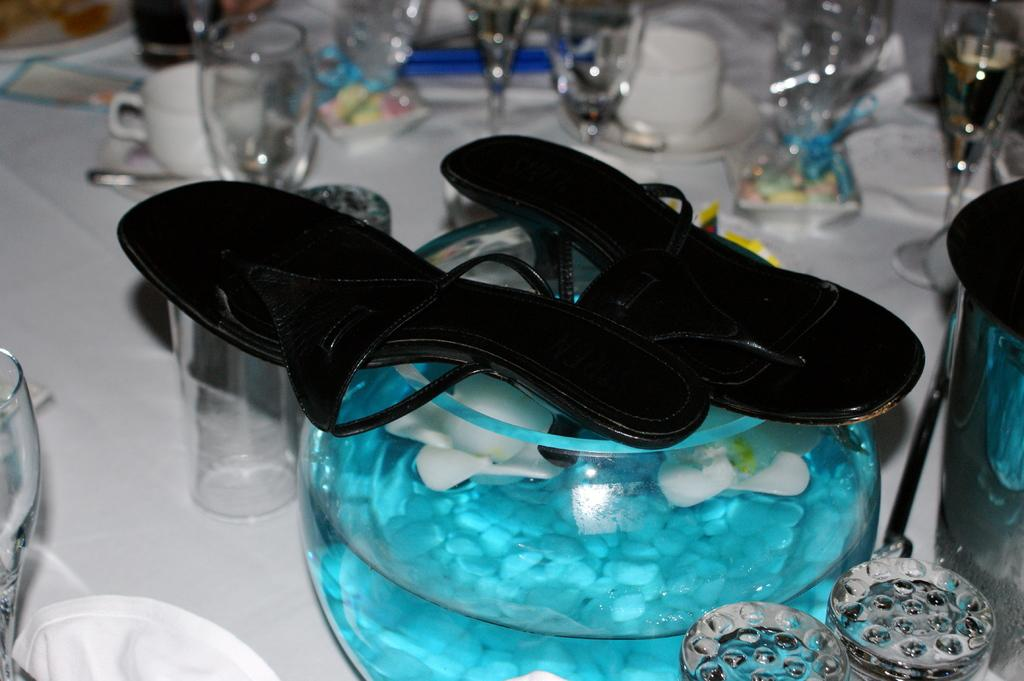What type of footwear is visible in the image? There is footwear in the image, but the specific type cannot be determined from the provided facts. What can be seen on the surface in the image? There are glass objects on a surface in the image. What type of scissors can be seen in the image? There is no mention of scissors in the provided facts, so it cannot be determined if they are present in the image. How does the mind appear in the image? The concept of a mind is not a physical object that can be seen in an image, so it cannot be present in the image. 